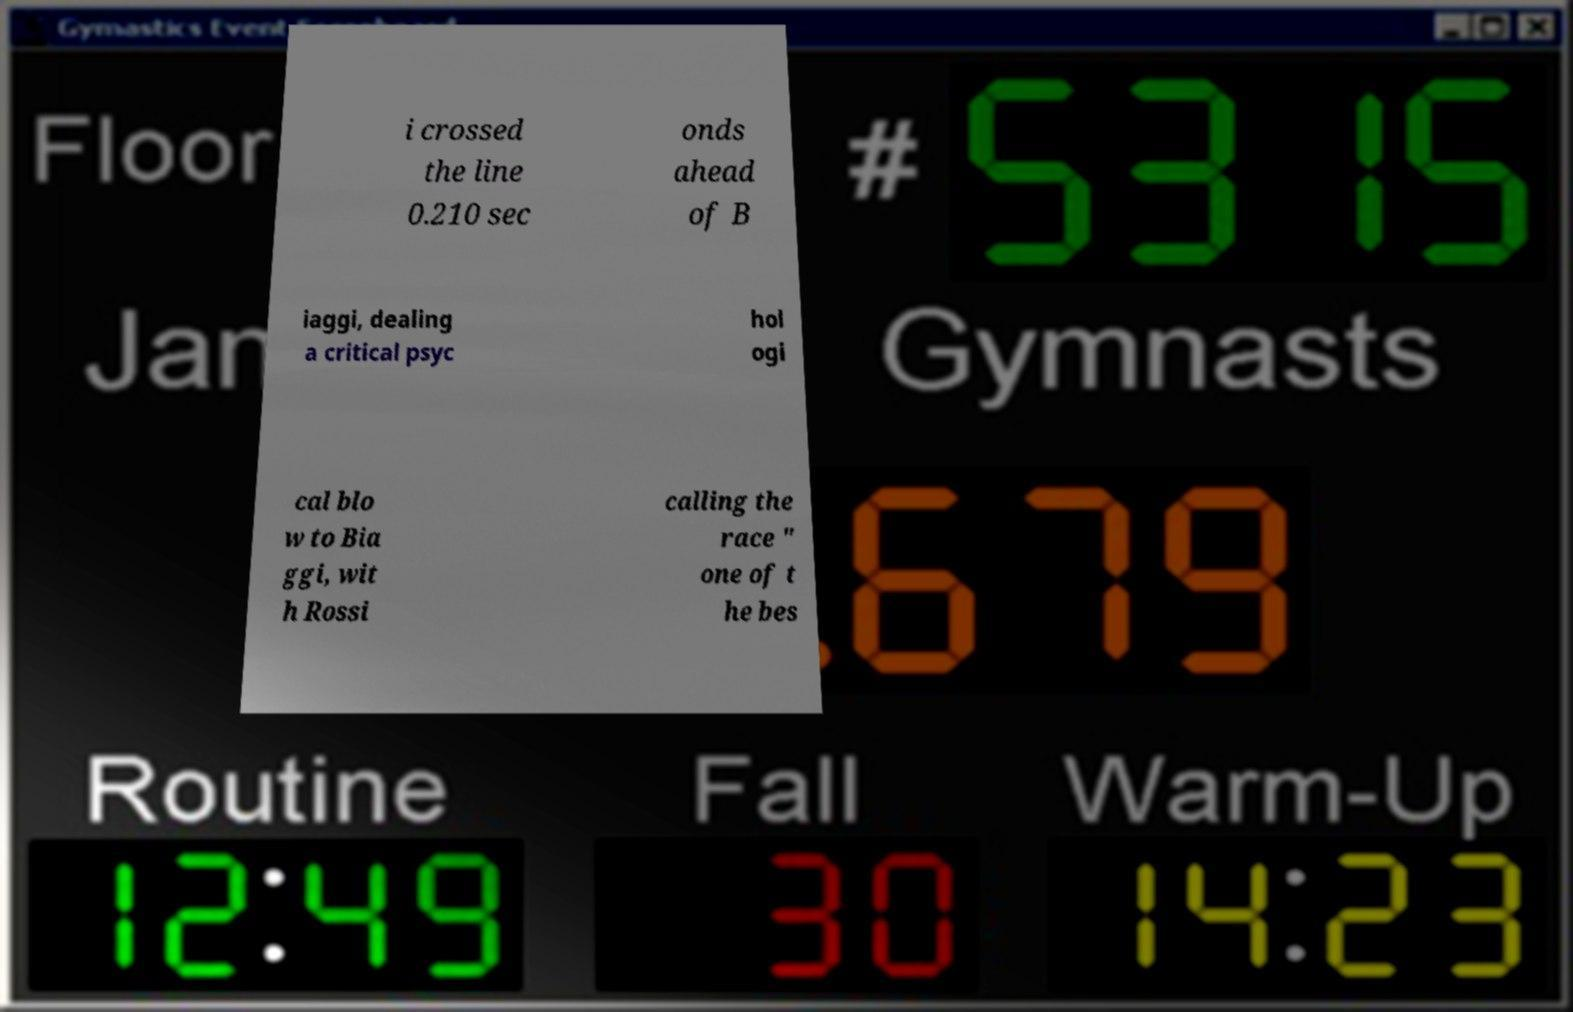Can you read and provide the text displayed in the image?This photo seems to have some interesting text. Can you extract and type it out for me? i crossed the line 0.210 sec onds ahead of B iaggi, dealing a critical psyc hol ogi cal blo w to Bia ggi, wit h Rossi calling the race " one of t he bes 